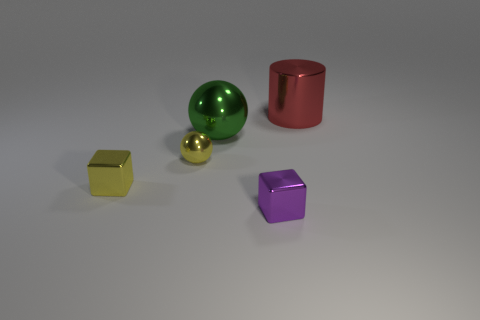Add 4 large green spheres. How many objects exist? 9 Subtract all cylinders. How many objects are left? 4 Add 1 yellow cubes. How many yellow cubes exist? 2 Subtract 0 brown blocks. How many objects are left? 5 Subtract all large cyan metallic balls. Subtract all yellow cubes. How many objects are left? 4 Add 5 big green things. How many big green things are left? 6 